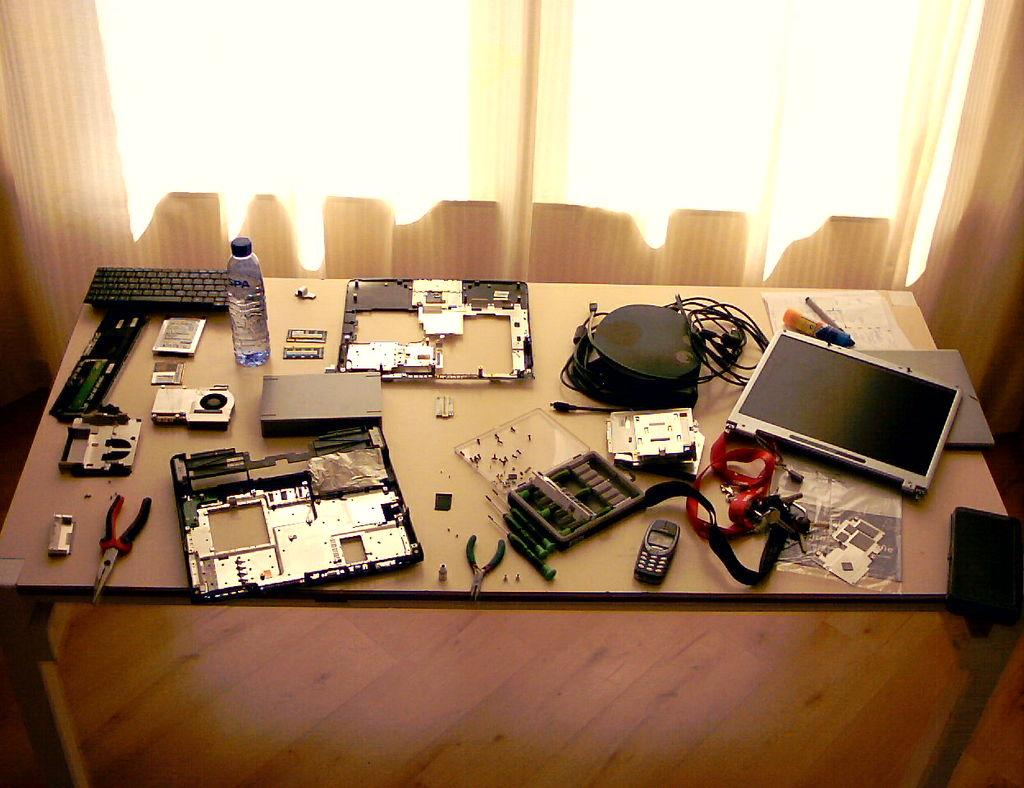What piece of furniture is in the image? There is a table in the image. What electronic device is on the table? A keyboard is present on the table. What type of container is on the table? There is a bottle on the table. What communication device is on the table? A mobile phone is visible on the table. What tool is on the table? A screwdriver is on the table. What type of wiring is on the table? There are wires on the table. What artistic item is on the table? A sketch is on the table. What type of paper is on the table? Papers are on the table. What unidentified device is on the table? There is a device on the table. What window treatment is present in the image? Curtains are present near a window. What type of disease is being advertised on the table? There is no advertisement present on the table, and therefore no disease is being advertised. How many planes are visible on the table? There are no planes visible on the table. 